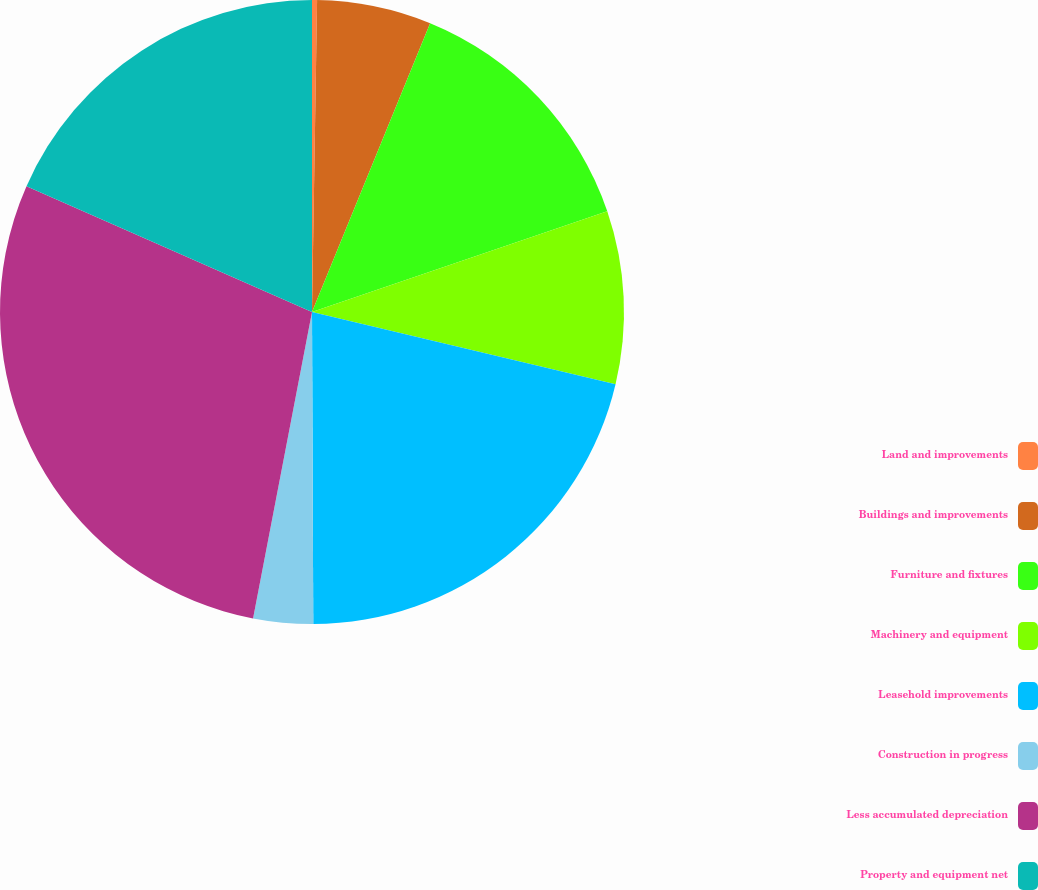Convert chart. <chart><loc_0><loc_0><loc_500><loc_500><pie_chart><fcel>Land and improvements<fcel>Buildings and improvements<fcel>Furniture and fixtures<fcel>Machinery and equipment<fcel>Leasehold improvements<fcel>Construction in progress<fcel>Less accumulated depreciation<fcel>Property and equipment net<nl><fcel>0.26%<fcel>5.92%<fcel>13.58%<fcel>8.95%<fcel>21.22%<fcel>3.09%<fcel>28.58%<fcel>18.39%<nl></chart> 